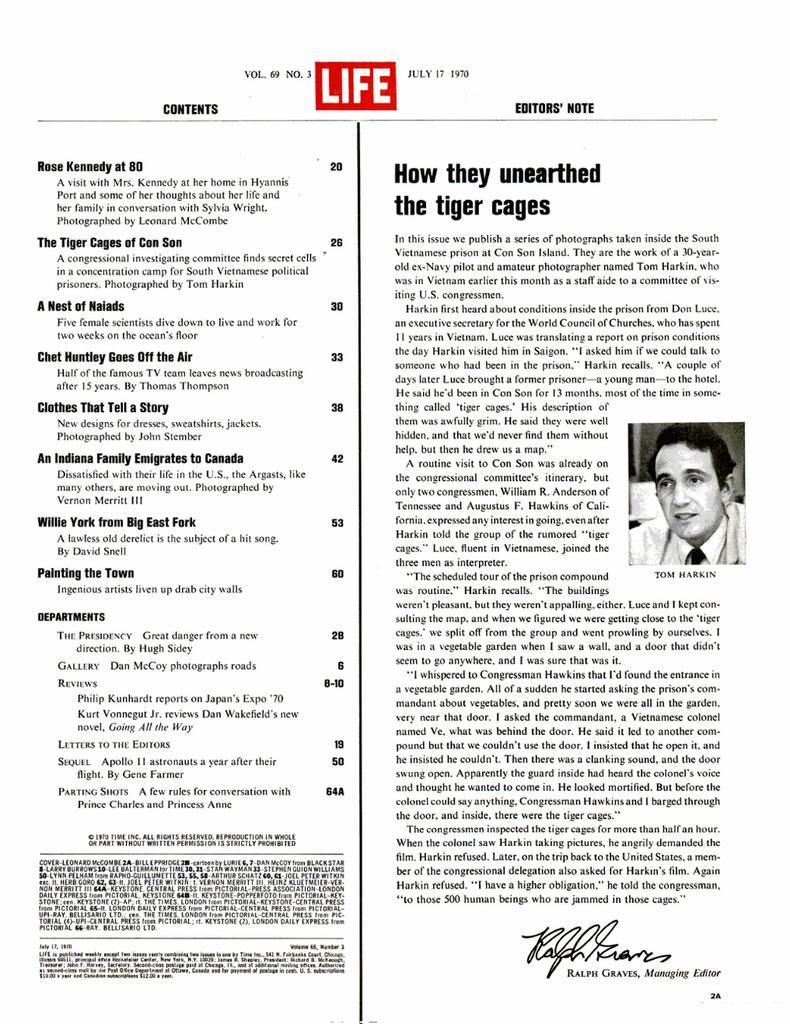Could you give a brief overview of what you see in this image? In the image there is a picture of a page, it has different contents and notes. There is a picture on the right side of the image. 